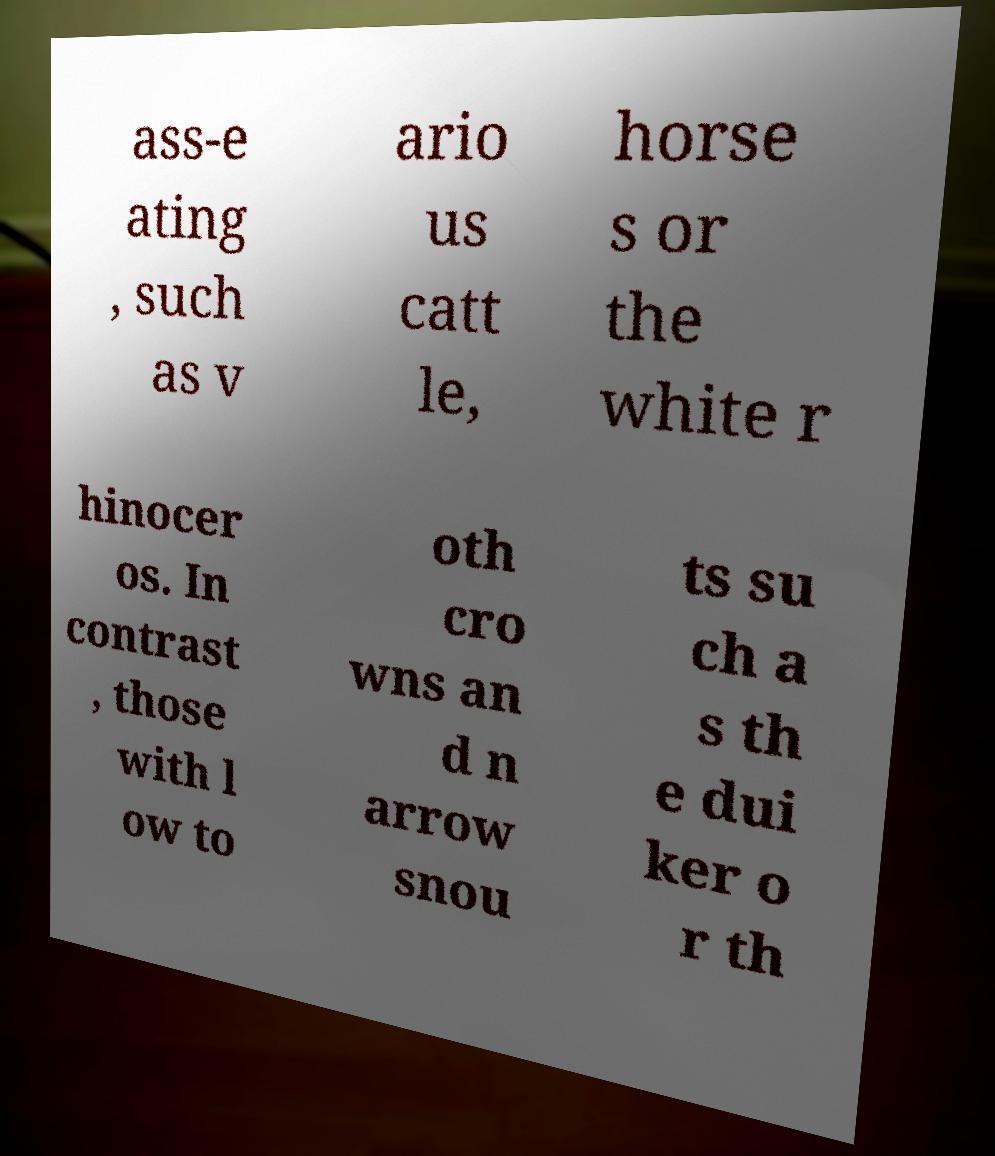For documentation purposes, I need the text within this image transcribed. Could you provide that? ass-e ating , such as v ario us catt le, horse s or the white r hinocer os. In contrast , those with l ow to oth cro wns an d n arrow snou ts su ch a s th e dui ker o r th 